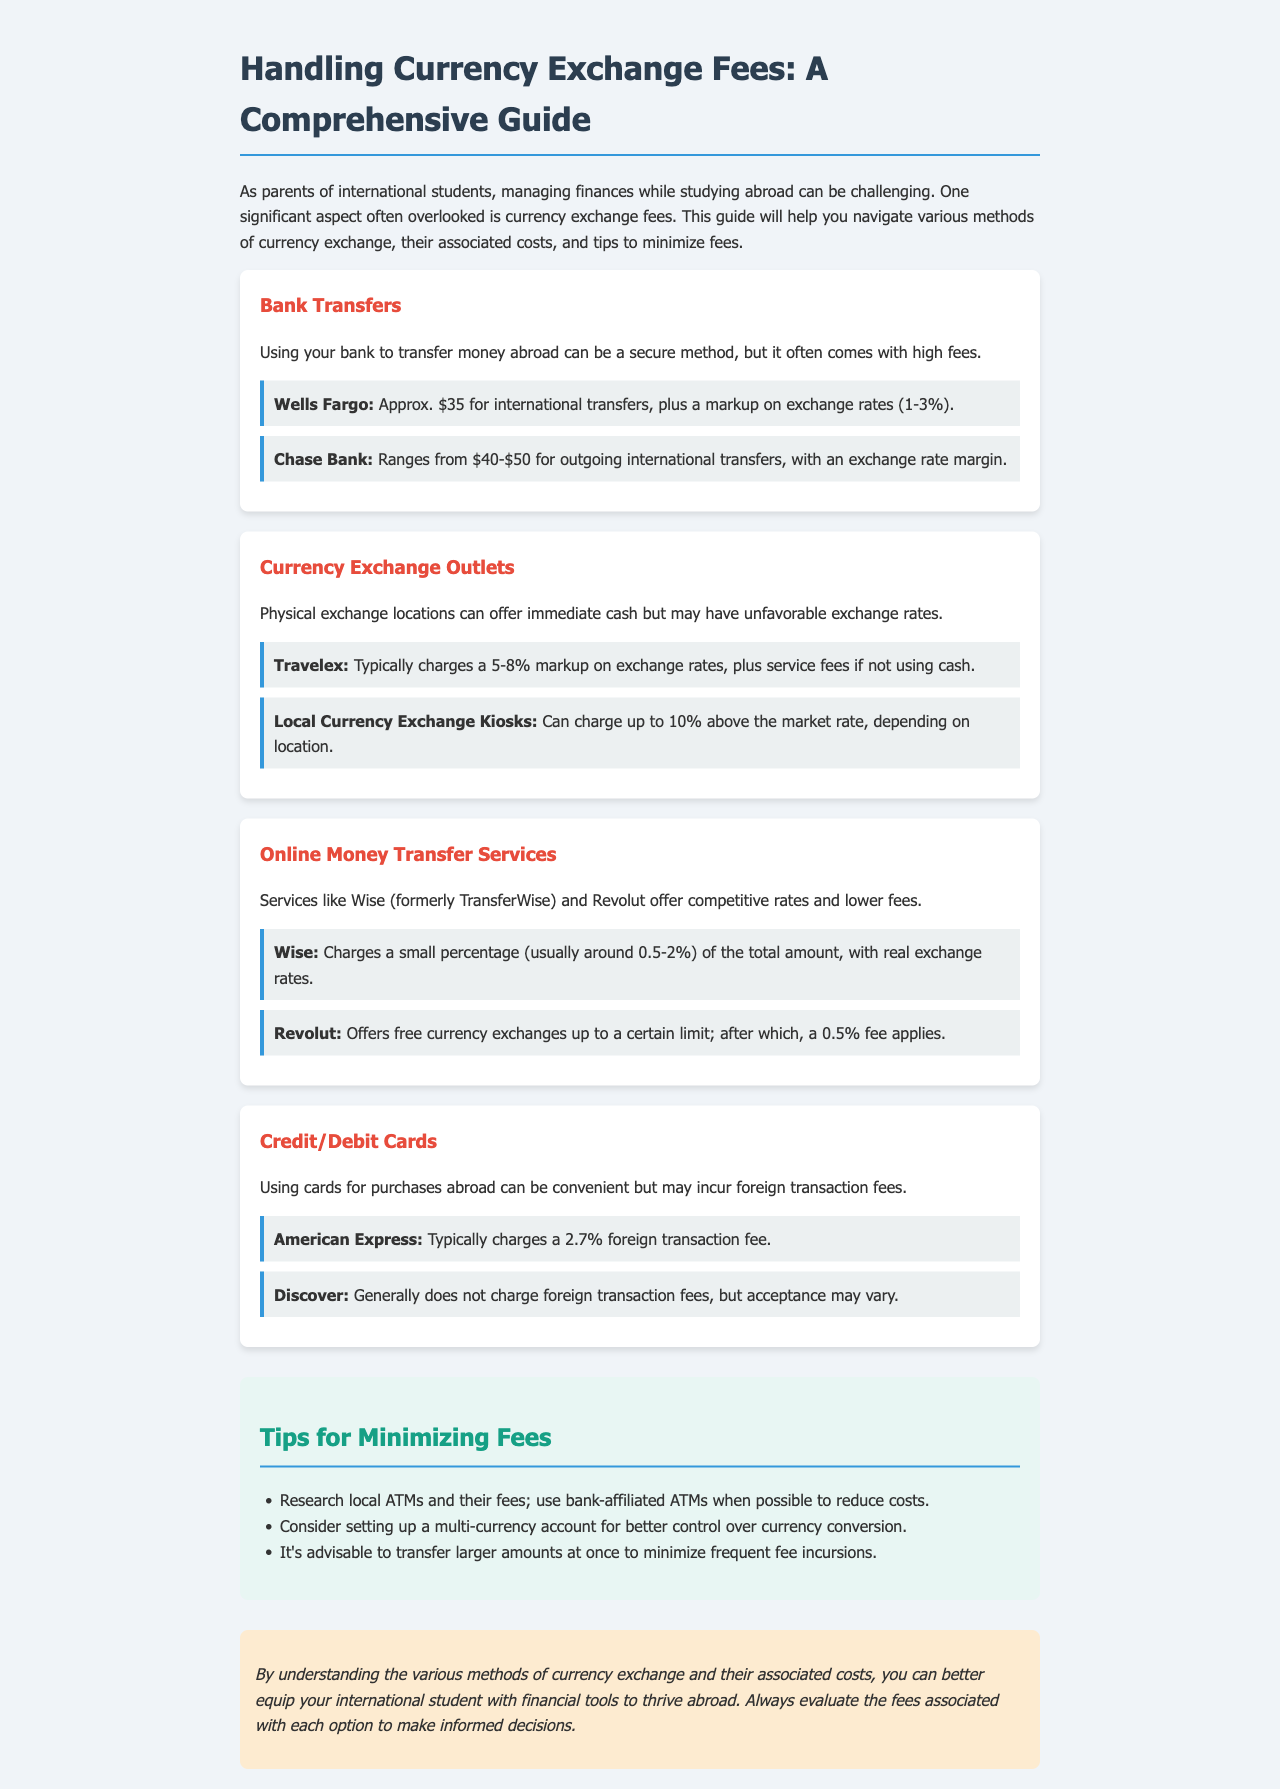What is the fee for Wells Fargo international transfers? The fee for Wells Fargo international transfers is approximately $35, plus a markup on exchange rates.
Answer: $35 What percentage does Wise charge for transfers? Wise charges a small percentage, usually around 0.5-2% of the total amount.
Answer: 0.5-2% What is the markup percentage typically charged by Travelex? Travelex typically charges a markup of 5-8% on exchange rates.
Answer: 5-8% Which bank generally does not charge foreign transaction fees? Discover generally does not charge foreign transaction fees.
Answer: Discover What is a suggested tip to minimize fees when transferring money? A suggested tip is to transfer larger amounts at once to minimize frequent fee incursions.
Answer: Transfer larger amounts at once 